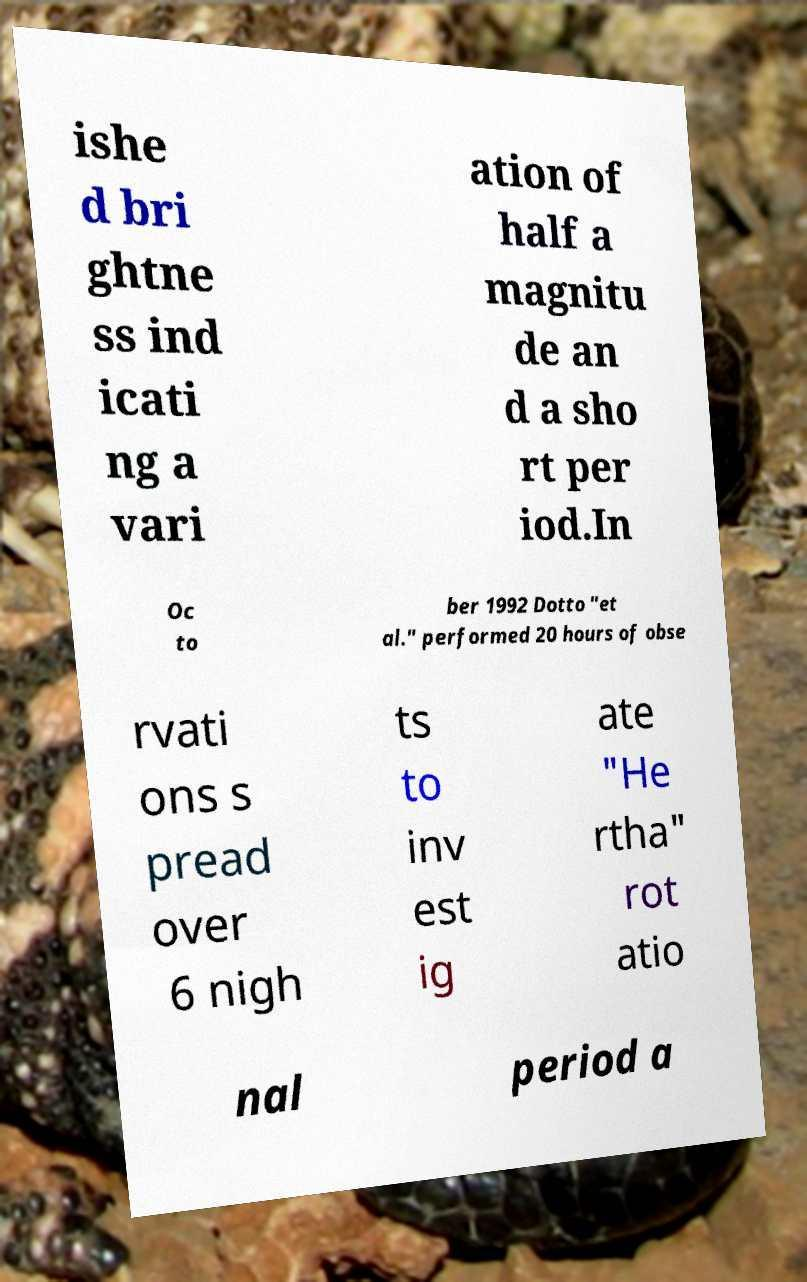Can you read and provide the text displayed in the image?This photo seems to have some interesting text. Can you extract and type it out for me? ishe d bri ghtne ss ind icati ng a vari ation of half a magnitu de an d a sho rt per iod.In Oc to ber 1992 Dotto "et al." performed 20 hours of obse rvati ons s pread over 6 nigh ts to inv est ig ate "He rtha" rot atio nal period a 